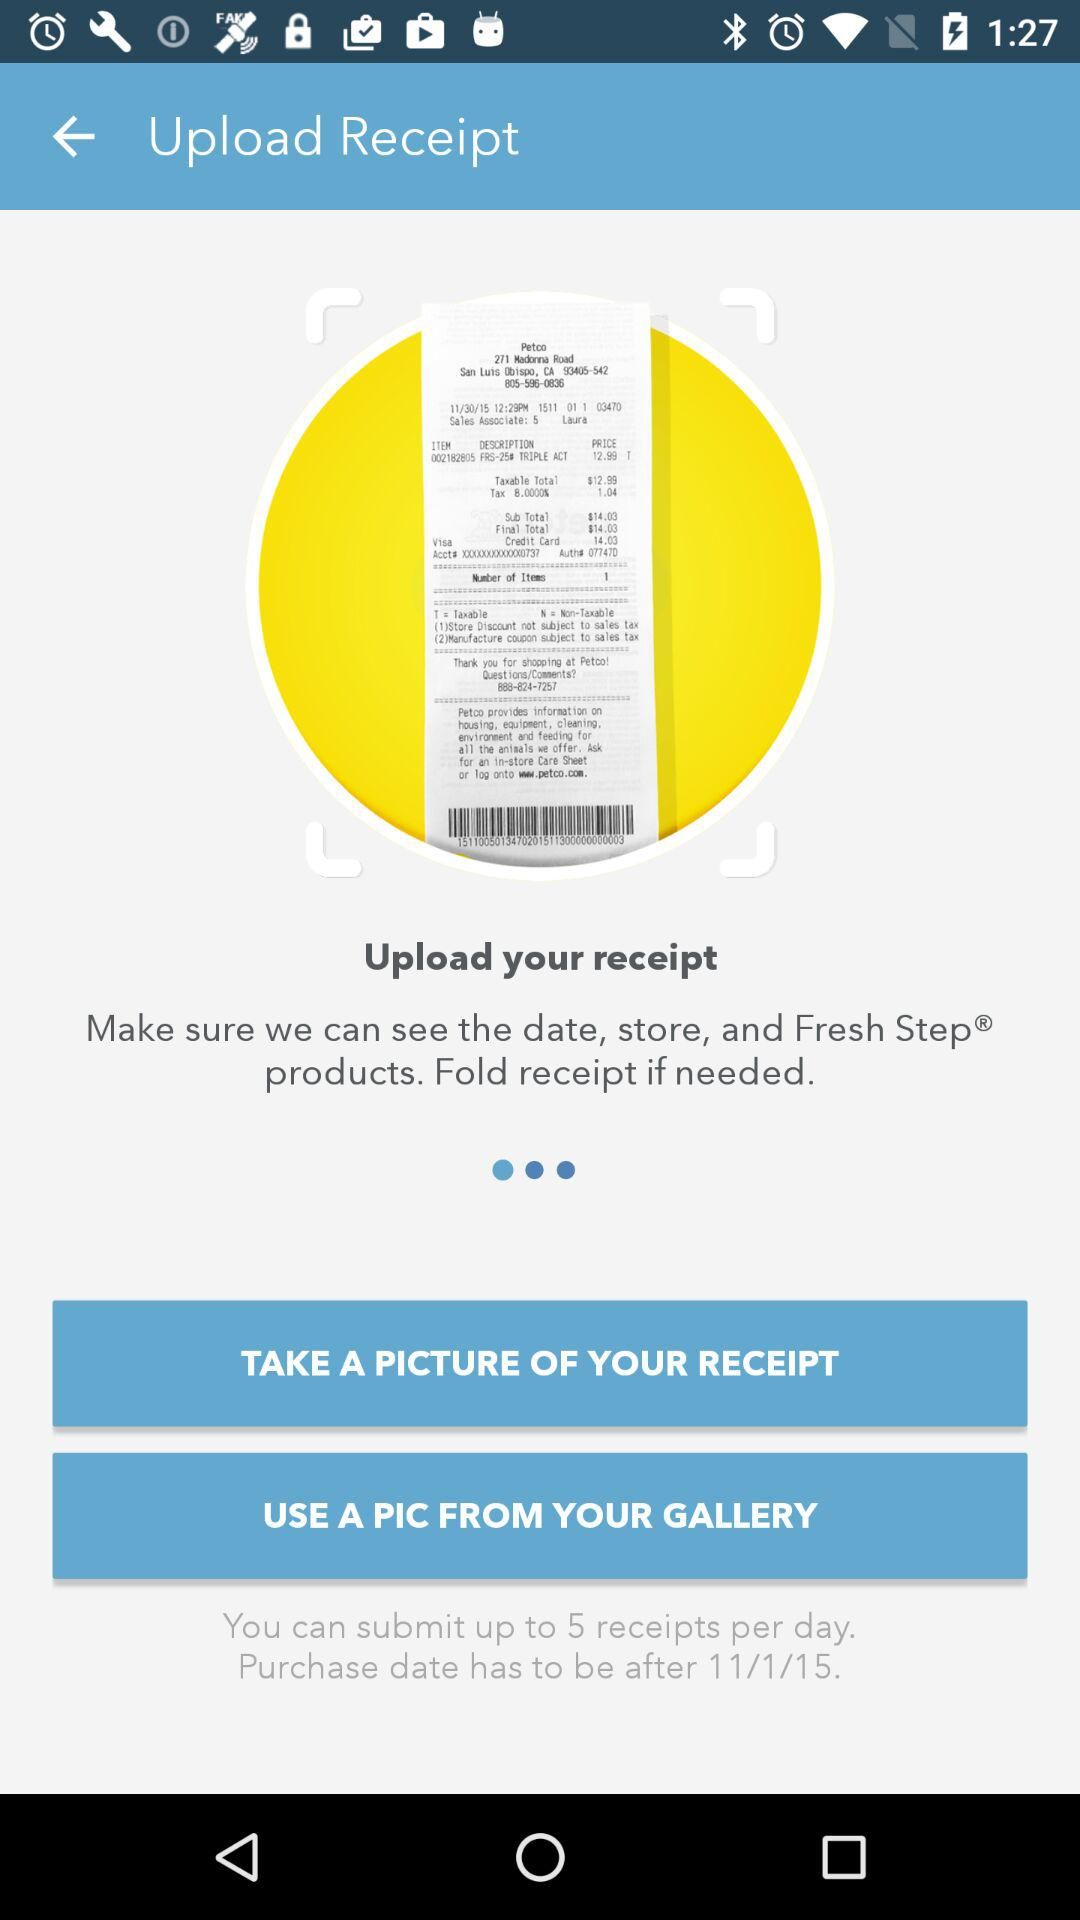What should be the purchase date? The purchase date should be after November 1, 2015. 